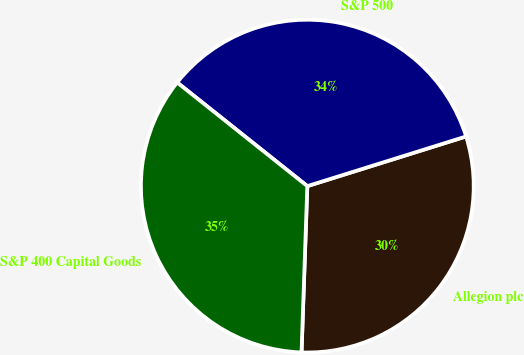Convert chart. <chart><loc_0><loc_0><loc_500><loc_500><pie_chart><fcel>Allegion plc<fcel>S&P 500<fcel>S&P 400 Capital Goods<nl><fcel>30.38%<fcel>34.47%<fcel>35.15%<nl></chart> 